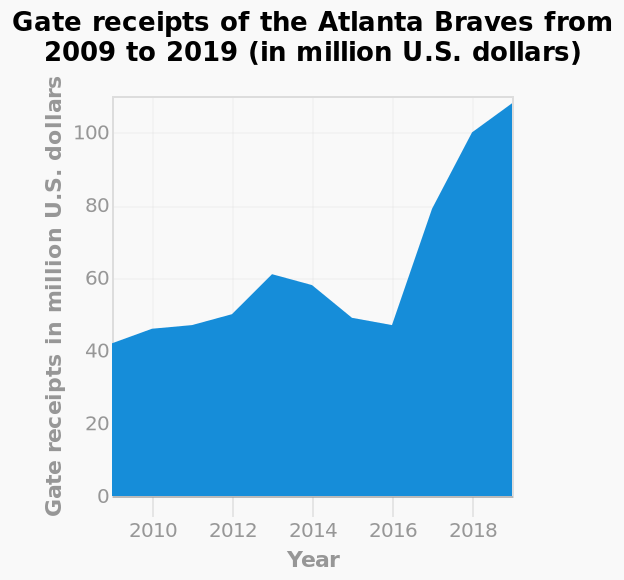<image>
When did the gate receipts increase rapidly? The gate receipts increased rapidly between 2016-18. What is the trend of gate receipts between 2016-18?  The gate receipts have shown a fluctuating pattern and then experienced a rapid increase between 2016-18. 